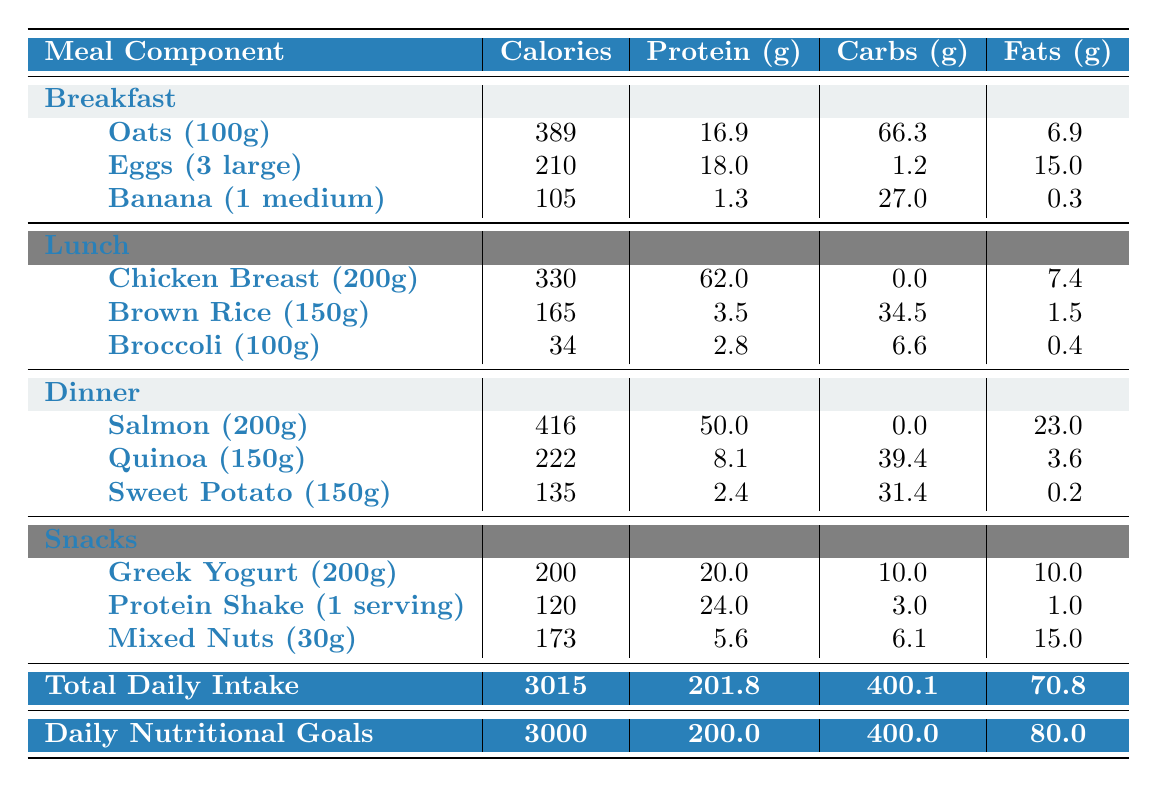What is the total calorie intake from snacks? The calorie intake from snacks is the sum of calories from Greek Yogurt (200), Protein Shake (120), and Mixed Nuts (173). Calculating this gives: 200 + 120 + 173 = 493.
Answer: 493 How many grams of protein are consumed in breakfast? In breakfast, the protein intake is from Oats (16.9), Eggs (18.0), and Banana (1.3). Adding these gives: 16.9 + 18.0 + 1.3 = 36.2 grams.
Answer: 36.2 Is the total carbohydrate intake higher than the daily goal? The total carbohydrate intake is 400.1 grams, while the daily goal is 400.0 grams. Comparing these, 400.1 is greater than 400.0, which confirms that the total is indeed higher.
Answer: Yes What is the difference in fat content between the total intake and the daily nutritional goal? The total fat intake is 70.8 grams, and the daily goal is 80.0 grams. The difference is 80.0 - 70.8 = 9.2 grams, showing the intake is lower than the goal.
Answer: 9.2 Which meal provides the highest protein content? Evaluating the protein from each meal: Breakfast total = 36.2g, Lunch total = 68.3g (62g from Chicken Breast + 3.5g Brown Rice + 2.8g Broccoli), Dinner total = 60.5g (50g Salmon + 8.1g Quinoa + 2.4g Sweet Potato), Snacks total = 49.6g. The highest is Lunch with 68.3g.
Answer: Lunch What is the average calorie consumption per meal? Total calorie consumption is 3015 across four meals. Therefore, dividing this by 4 gives: 3015 / 4 = 753.75. This is the average calorie intake per meal.
Answer: 753.75 If I consumed only the Lunch meal, would I meet my daily protein goal? The protein from Lunch is 68.3 grams, which does not meet the daily goal of 200 grams. Therefore, it is clear that Lunch alone is insufficient to meet the daily requirement.
Answer: No How much more fat can I consume to meet my daily fat goal? The total fat intake is 70.8 grams, and the daily goal is 80.0 grams. To find the remaining fat allowance, calculate: 80.0 - 70.8 = 9.2 grams.
Answer: 9.2 grams What percentage of the daily calorie goal is met by the total daily intake? Total daily intake is 3015 calories and the daily goal is 3000 calories. Thus, the percentage met is (3015 / 3000) * 100 = 100.5%.
Answer: 100.5% How many grams of carbohydrates are in the Dinner meal? The carbohydrates in Dinner consist of Quinoa (39.4g) and Sweet Potato (31.4g), with Salmon having 0g. Adding those gives 39.4 + 31.4 = 70.8 grams of carbohydrates in Dinner.
Answer: 70.8 